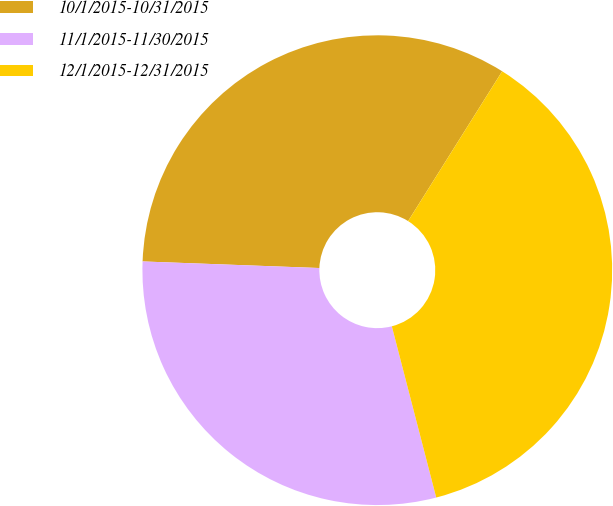Convert chart. <chart><loc_0><loc_0><loc_500><loc_500><pie_chart><fcel>10/1/2015-10/31/2015<fcel>11/1/2015-11/30/2015<fcel>12/1/2015-12/31/2015<nl><fcel>33.33%<fcel>29.63%<fcel>37.04%<nl></chart> 